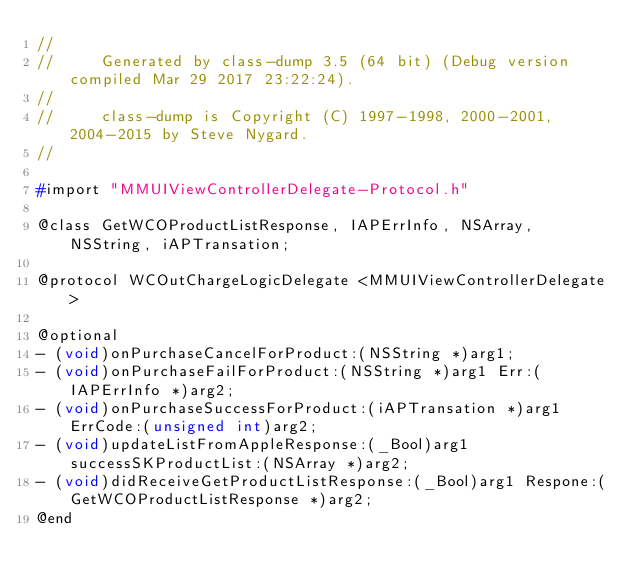Convert code to text. <code><loc_0><loc_0><loc_500><loc_500><_C_>//
//     Generated by class-dump 3.5 (64 bit) (Debug version compiled Mar 29 2017 23:22:24).
//
//     class-dump is Copyright (C) 1997-1998, 2000-2001, 2004-2015 by Steve Nygard.
//

#import "MMUIViewControllerDelegate-Protocol.h"

@class GetWCOProductListResponse, IAPErrInfo, NSArray, NSString, iAPTransation;

@protocol WCOutChargeLogicDelegate <MMUIViewControllerDelegate>

@optional
- (void)onPurchaseCancelForProduct:(NSString *)arg1;
- (void)onPurchaseFailForProduct:(NSString *)arg1 Err:(IAPErrInfo *)arg2;
- (void)onPurchaseSuccessForProduct:(iAPTransation *)arg1 ErrCode:(unsigned int)arg2;
- (void)updateListFromAppleResponse:(_Bool)arg1 successSKProductList:(NSArray *)arg2;
- (void)didReceiveGetProductListResponse:(_Bool)arg1 Respone:(GetWCOProductListResponse *)arg2;
@end

</code> 